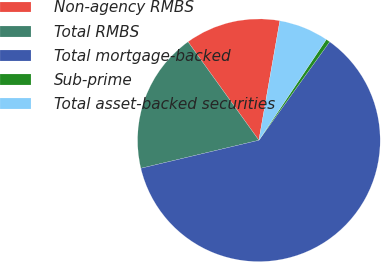Convert chart to OTSL. <chart><loc_0><loc_0><loc_500><loc_500><pie_chart><fcel>Non-agency RMBS<fcel>Total RMBS<fcel>Total mortgage-backed<fcel>Sub-prime<fcel>Total asset-backed securities<nl><fcel>12.7%<fcel>18.78%<fcel>61.37%<fcel>0.53%<fcel>6.62%<nl></chart> 